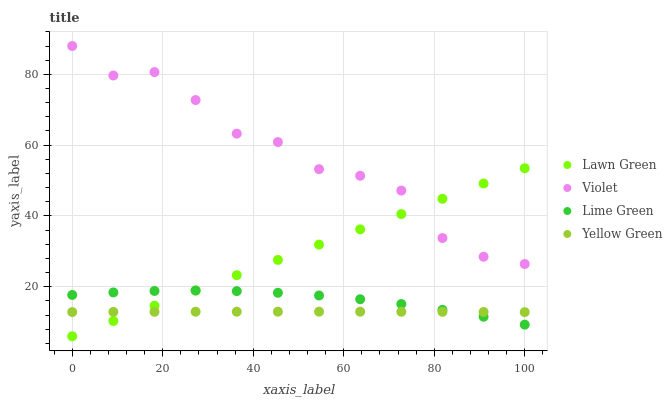Does Yellow Green have the minimum area under the curve?
Answer yes or no. Yes. Does Violet have the maximum area under the curve?
Answer yes or no. Yes. Does Lime Green have the minimum area under the curve?
Answer yes or no. No. Does Lime Green have the maximum area under the curve?
Answer yes or no. No. Is Lawn Green the smoothest?
Answer yes or no. Yes. Is Violet the roughest?
Answer yes or no. Yes. Is Lime Green the smoothest?
Answer yes or no. No. Is Lime Green the roughest?
Answer yes or no. No. Does Lawn Green have the lowest value?
Answer yes or no. Yes. Does Lime Green have the lowest value?
Answer yes or no. No. Does Violet have the highest value?
Answer yes or no. Yes. Does Lime Green have the highest value?
Answer yes or no. No. Is Lime Green less than Violet?
Answer yes or no. Yes. Is Violet greater than Yellow Green?
Answer yes or no. Yes. Does Yellow Green intersect Lawn Green?
Answer yes or no. Yes. Is Yellow Green less than Lawn Green?
Answer yes or no. No. Is Yellow Green greater than Lawn Green?
Answer yes or no. No. Does Lime Green intersect Violet?
Answer yes or no. No. 